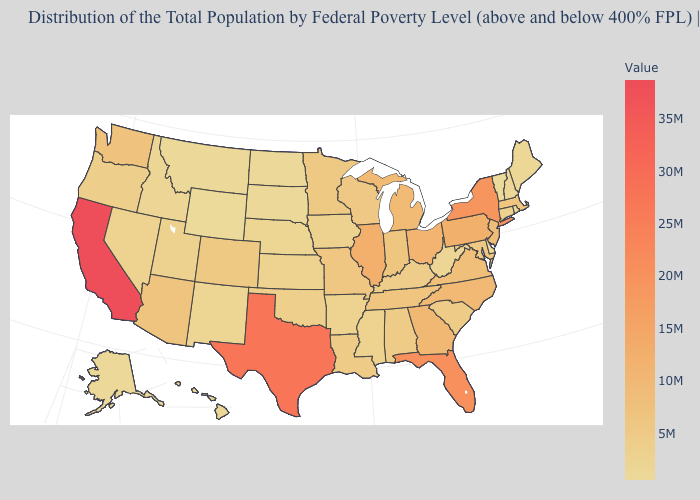Which states have the highest value in the USA?
Give a very brief answer. California. Which states hav the highest value in the West?
Give a very brief answer. California. Does Nevada have the lowest value in the USA?
Quick response, please. No. Does New Hampshire have a higher value than Indiana?
Give a very brief answer. No. Among the states that border Arizona , does California have the highest value?
Answer briefly. Yes. Does California have the highest value in the USA?
Keep it brief. Yes. Among the states that border Florida , which have the highest value?
Give a very brief answer. Georgia. 